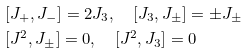<formula> <loc_0><loc_0><loc_500><loc_500>& [ J _ { + } , J _ { - } ] = 2 J _ { 3 } , \quad [ J _ { 3 } , J _ { \pm } ] = \pm J _ { \pm } \\ & [ J ^ { 2 } , J _ { \pm } ] = 0 , \quad [ J ^ { 2 } , J _ { 3 } ] = 0</formula> 